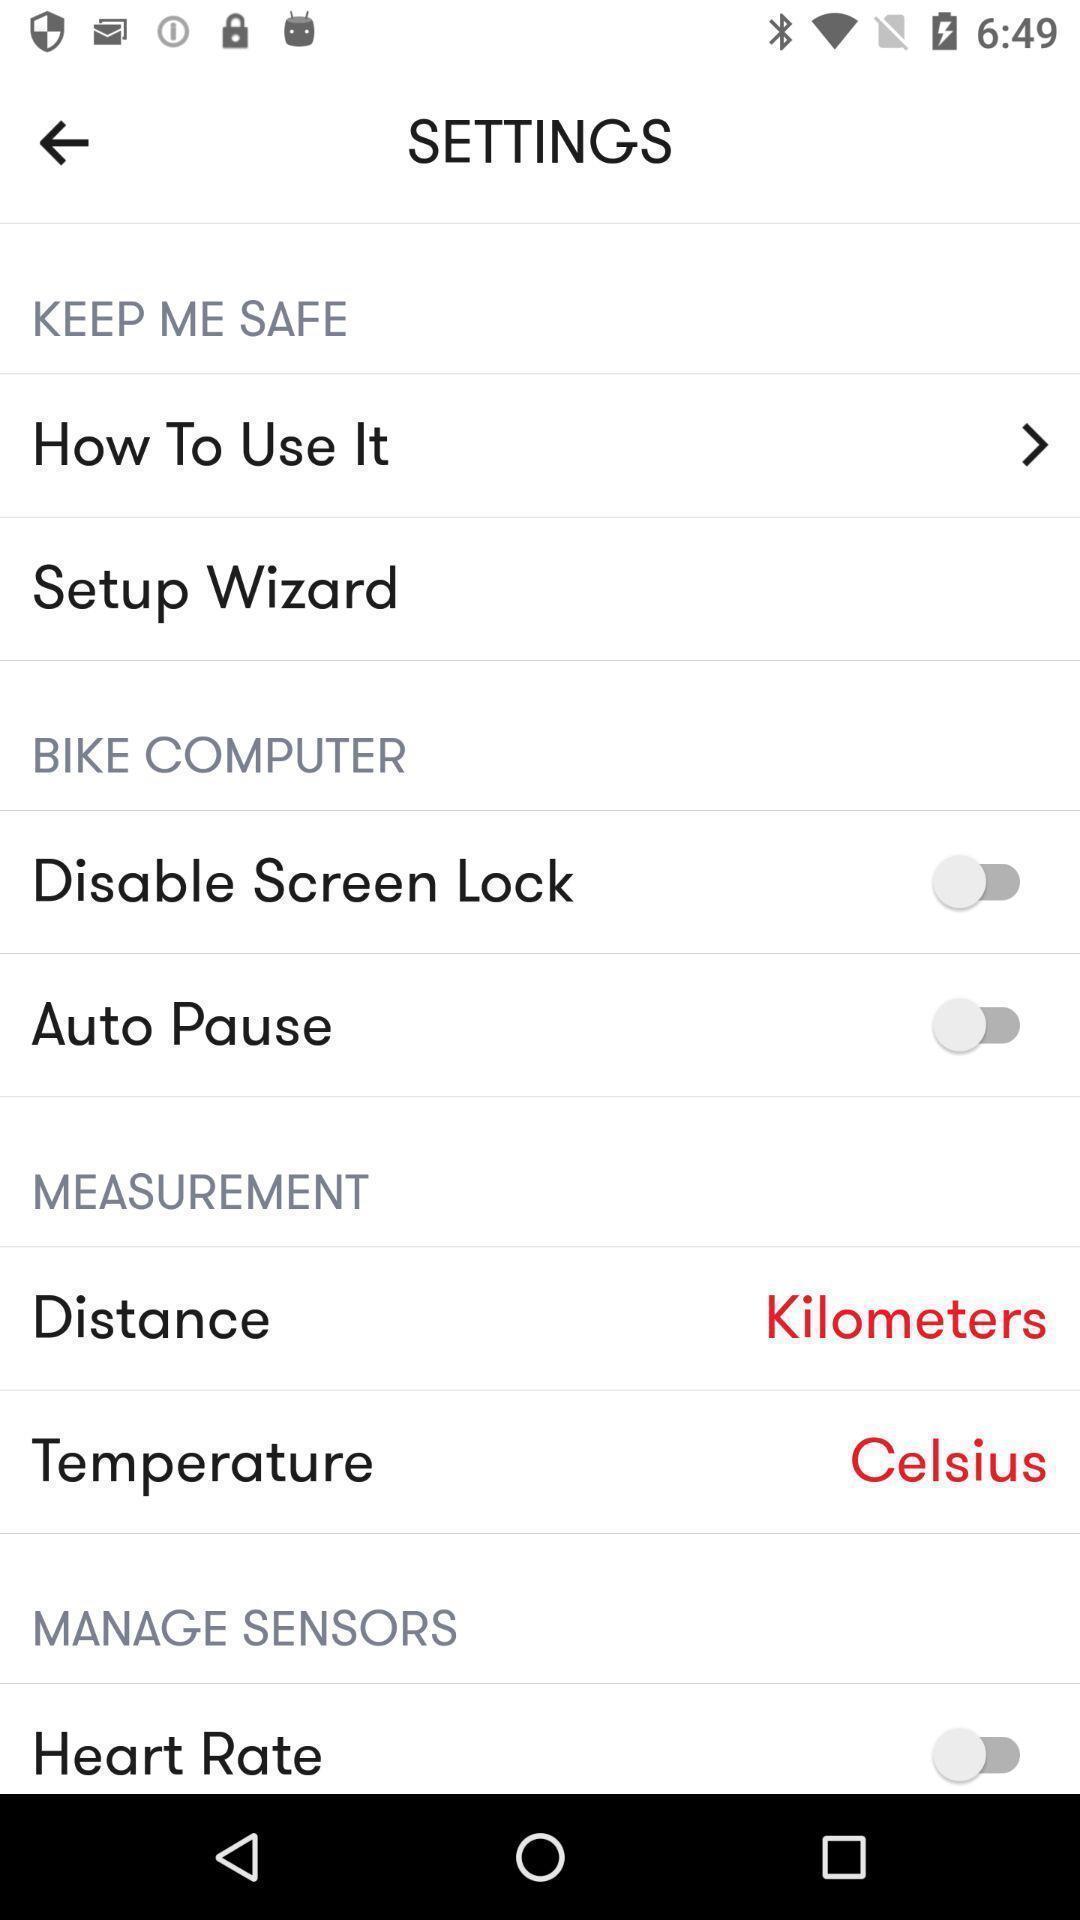Please provide a description for this image. Settings page. 